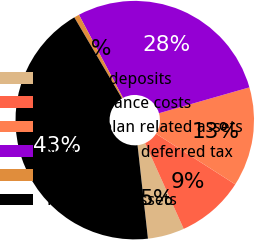<chart> <loc_0><loc_0><loc_500><loc_500><pie_chart><fcel>Security deposits<fcel>Debt issuance costs<fcel>Benefit plan related assets<fcel>Non-current deferred tax<fcel>Other<fcel>Total other assets<nl><fcel>4.97%<fcel>9.22%<fcel>13.48%<fcel>28.32%<fcel>0.71%<fcel>43.3%<nl></chart> 